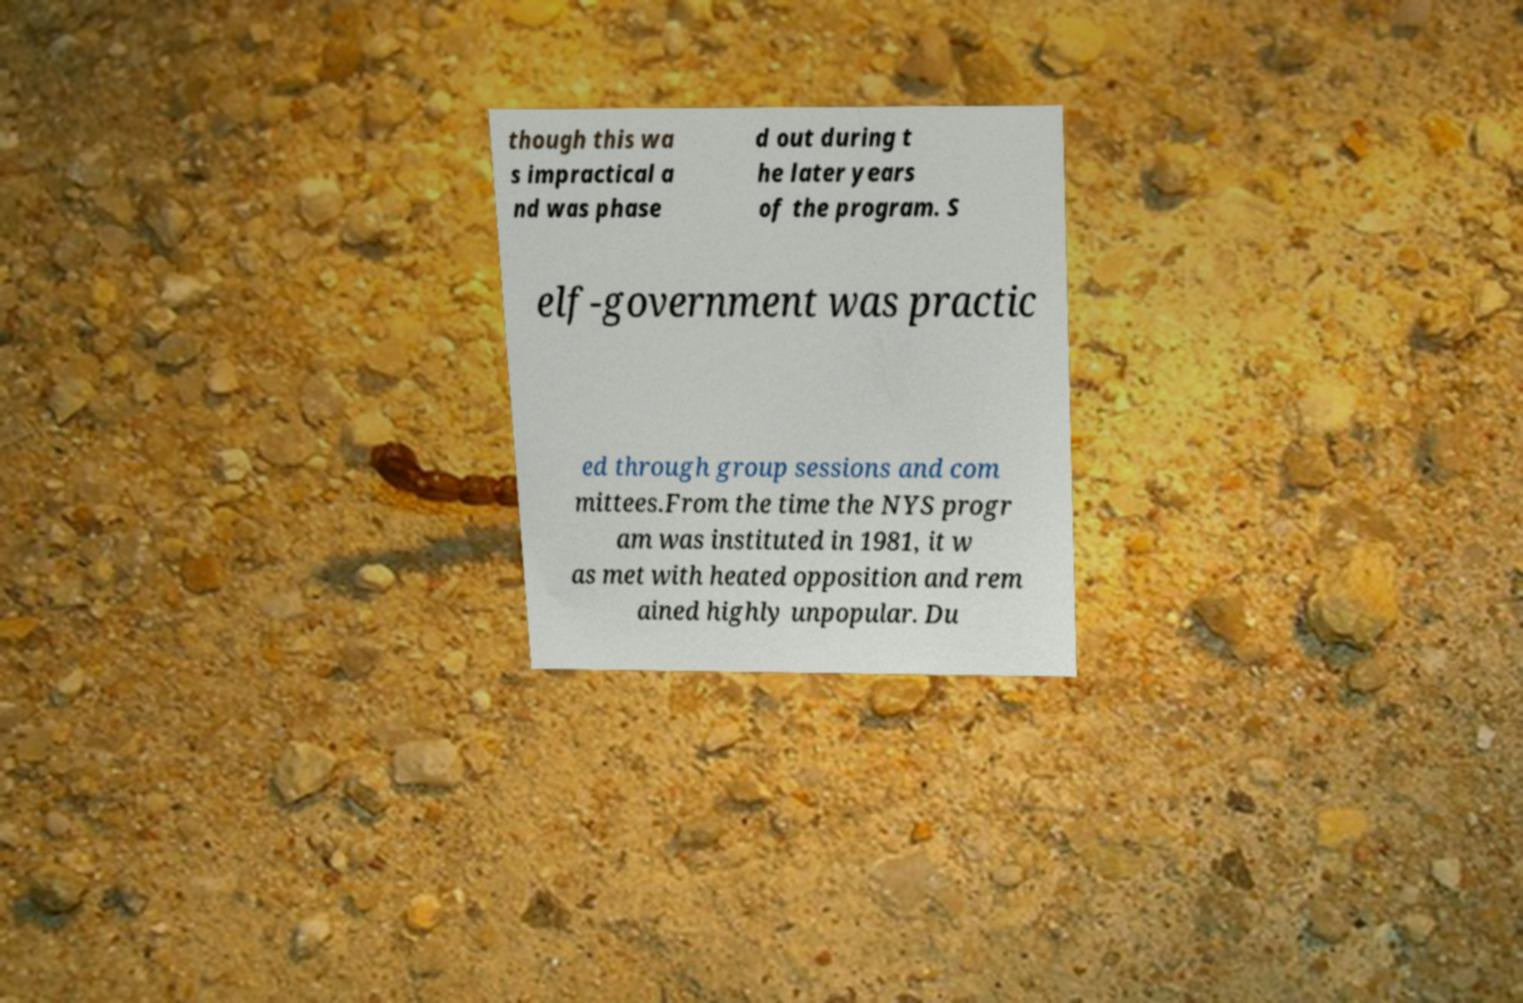Can you accurately transcribe the text from the provided image for me? though this wa s impractical a nd was phase d out during t he later years of the program. S elf-government was practic ed through group sessions and com mittees.From the time the NYS progr am was instituted in 1981, it w as met with heated opposition and rem ained highly unpopular. Du 